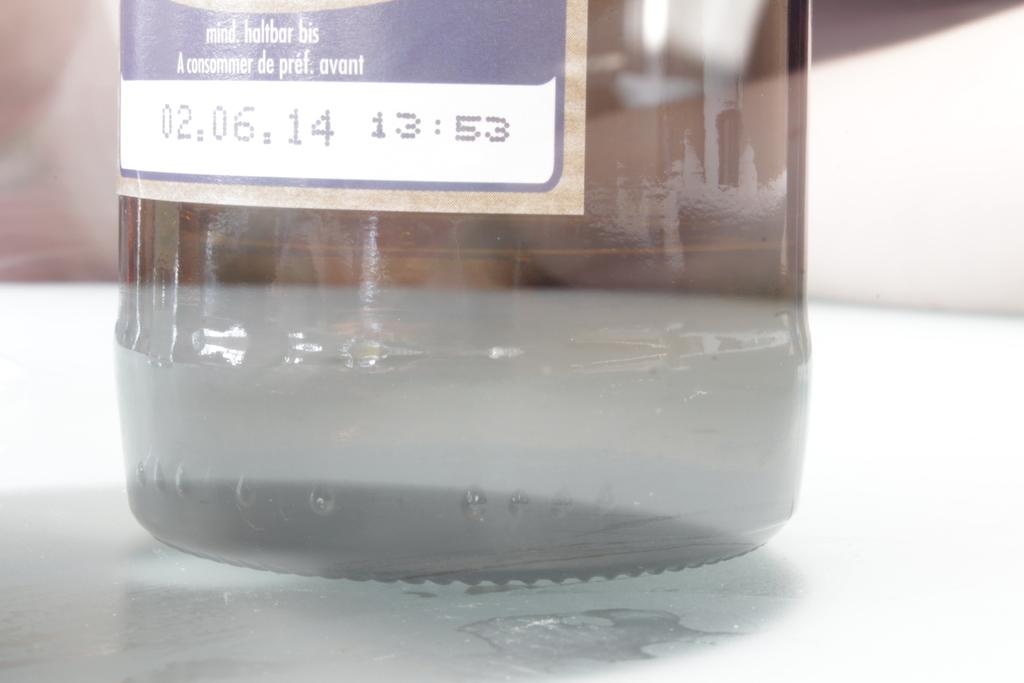Provide a one-sentence caption for the provided image. A clear bottle on a table with a date stamp of 02.06.14. 